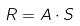<formula> <loc_0><loc_0><loc_500><loc_500>R = A \cdot S</formula> 